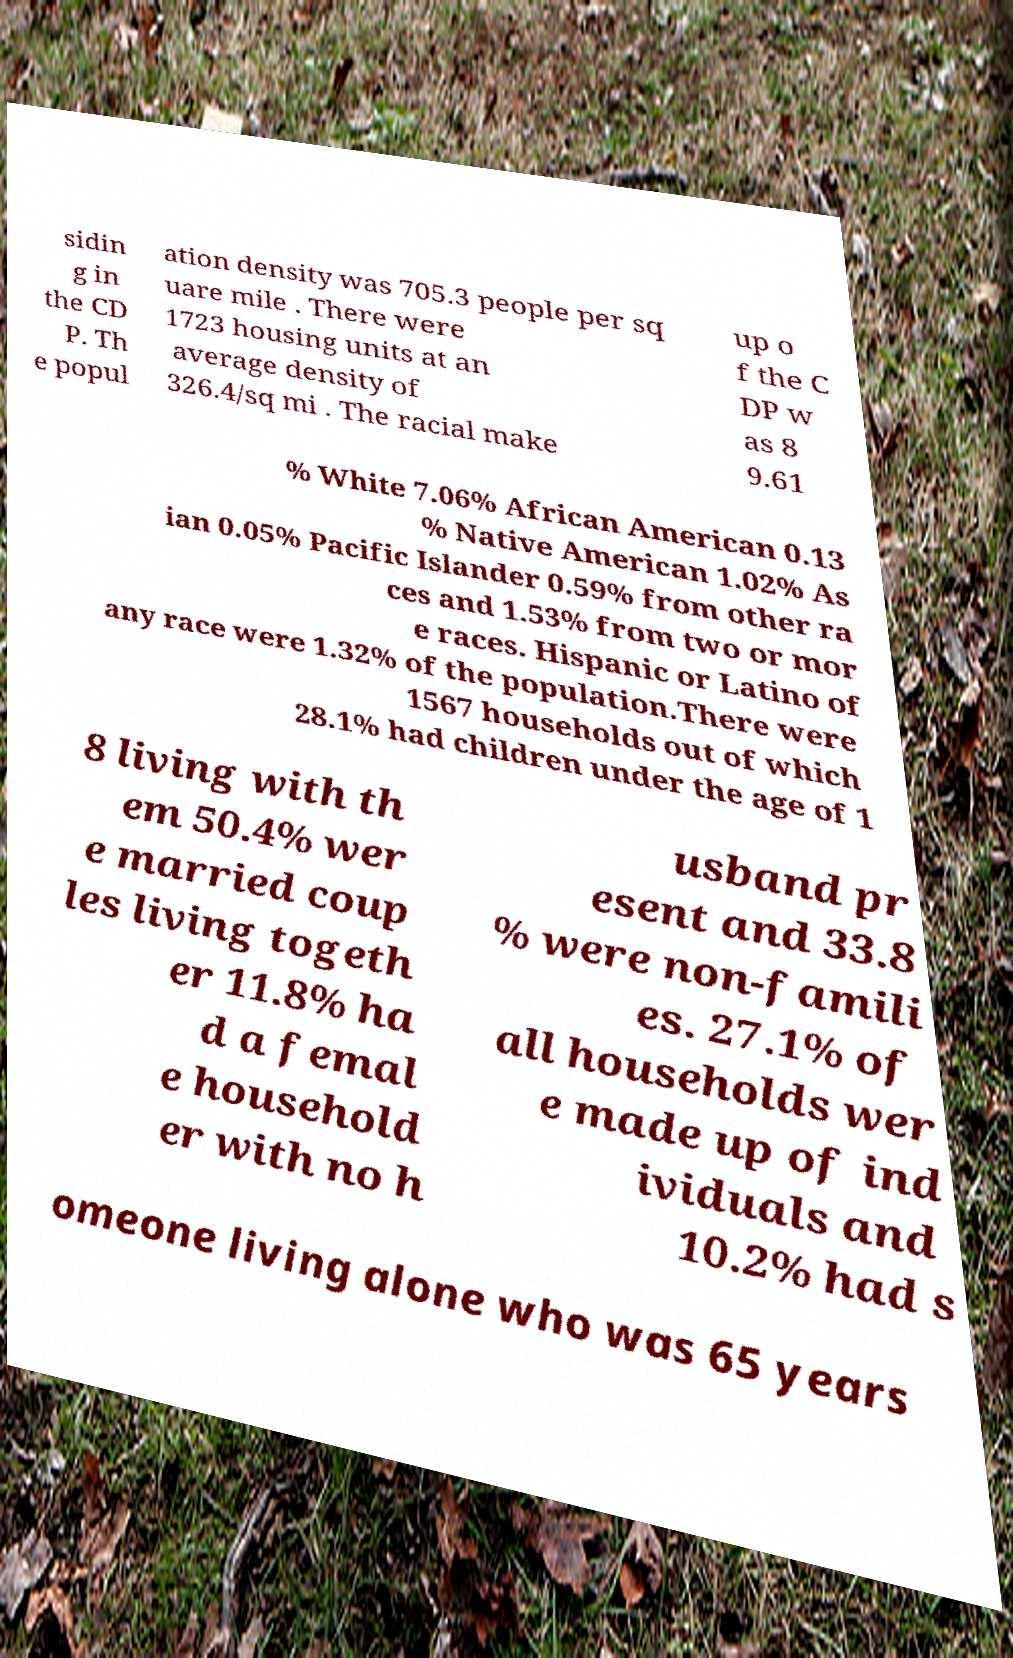Can you read and provide the text displayed in the image?This photo seems to have some interesting text. Can you extract and type it out for me? sidin g in the CD P. Th e popul ation density was 705.3 people per sq uare mile . There were 1723 housing units at an average density of 326.4/sq mi . The racial make up o f the C DP w as 8 9.61 % White 7.06% African American 0.13 % Native American 1.02% As ian 0.05% Pacific Islander 0.59% from other ra ces and 1.53% from two or mor e races. Hispanic or Latino of any race were 1.32% of the population.There were 1567 households out of which 28.1% had children under the age of 1 8 living with th em 50.4% wer e married coup les living togeth er 11.8% ha d a femal e household er with no h usband pr esent and 33.8 % were non-famili es. 27.1% of all households wer e made up of ind ividuals and 10.2% had s omeone living alone who was 65 years 